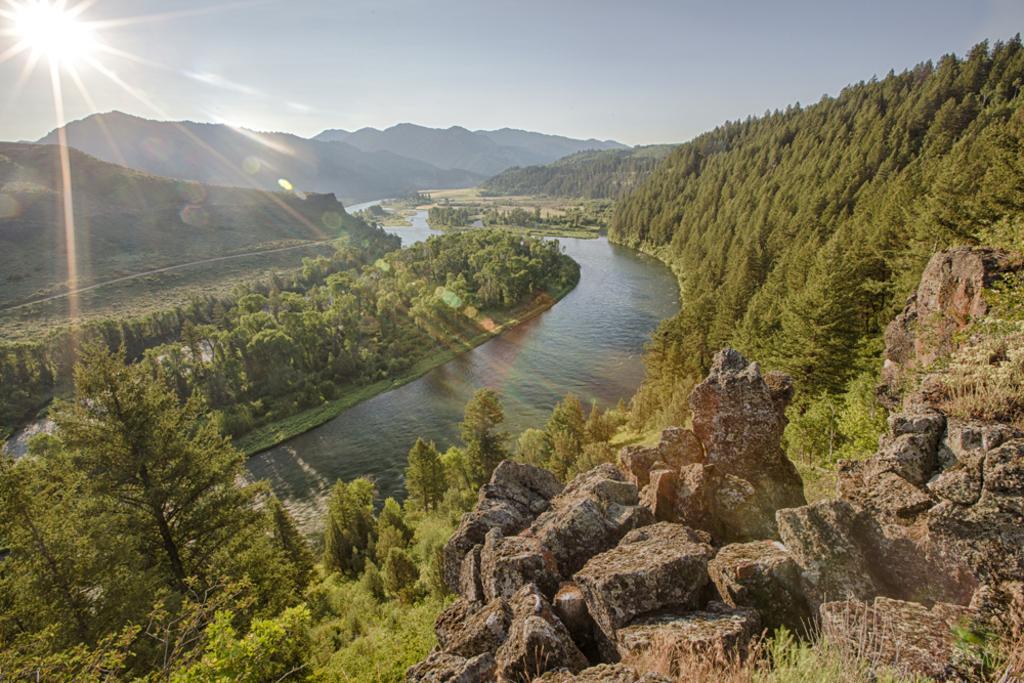In one or two sentences, can you explain what this image depicts? This picture is taken from outside of the city. In this image, on the right side, we can see some trees, plants, rocks. In the middle of the image, we can see some plants, trees. In the middle of the image, we can see water in a lake. On the left side, we can see some trees, plants. In the background, we can see some rocks, trees. At the top, we can see a sky and a sun. 